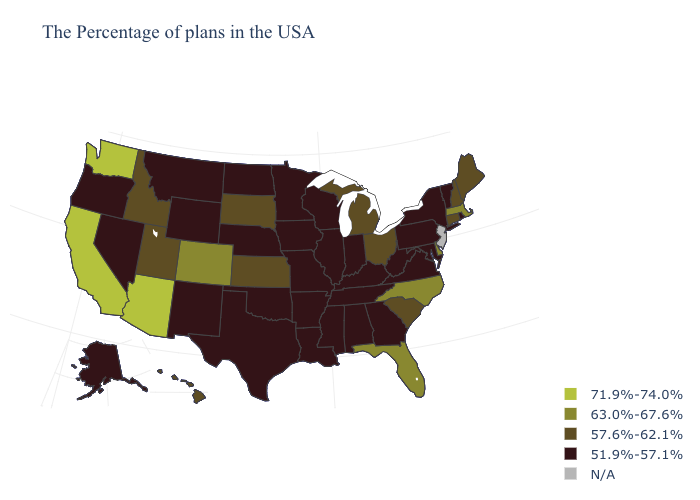What is the value of Kentucky?
Concise answer only. 51.9%-57.1%. What is the value of Mississippi?
Quick response, please. 51.9%-57.1%. Name the states that have a value in the range 63.0%-67.6%?
Answer briefly. Massachusetts, Delaware, North Carolina, Florida, Colorado. Name the states that have a value in the range 51.9%-57.1%?
Keep it brief. Rhode Island, Vermont, New York, Maryland, Pennsylvania, Virginia, West Virginia, Georgia, Kentucky, Indiana, Alabama, Tennessee, Wisconsin, Illinois, Mississippi, Louisiana, Missouri, Arkansas, Minnesota, Iowa, Nebraska, Oklahoma, Texas, North Dakota, Wyoming, New Mexico, Montana, Nevada, Oregon, Alaska. What is the lowest value in states that border Nebraska?
Write a very short answer. 51.9%-57.1%. What is the lowest value in states that border Illinois?
Keep it brief. 51.9%-57.1%. Does the map have missing data?
Answer briefly. Yes. Among the states that border Tennessee , does Arkansas have the highest value?
Short answer required. No. Name the states that have a value in the range N/A?
Concise answer only. New Jersey. What is the lowest value in states that border Vermont?
Answer briefly. 51.9%-57.1%. Which states have the lowest value in the USA?
Keep it brief. Rhode Island, Vermont, New York, Maryland, Pennsylvania, Virginia, West Virginia, Georgia, Kentucky, Indiana, Alabama, Tennessee, Wisconsin, Illinois, Mississippi, Louisiana, Missouri, Arkansas, Minnesota, Iowa, Nebraska, Oklahoma, Texas, North Dakota, Wyoming, New Mexico, Montana, Nevada, Oregon, Alaska. Does Indiana have the highest value in the MidWest?
Be succinct. No. What is the highest value in states that border Arizona?
Write a very short answer. 71.9%-74.0%. What is the highest value in states that border New Mexico?
Concise answer only. 71.9%-74.0%. Name the states that have a value in the range 63.0%-67.6%?
Quick response, please. Massachusetts, Delaware, North Carolina, Florida, Colorado. 